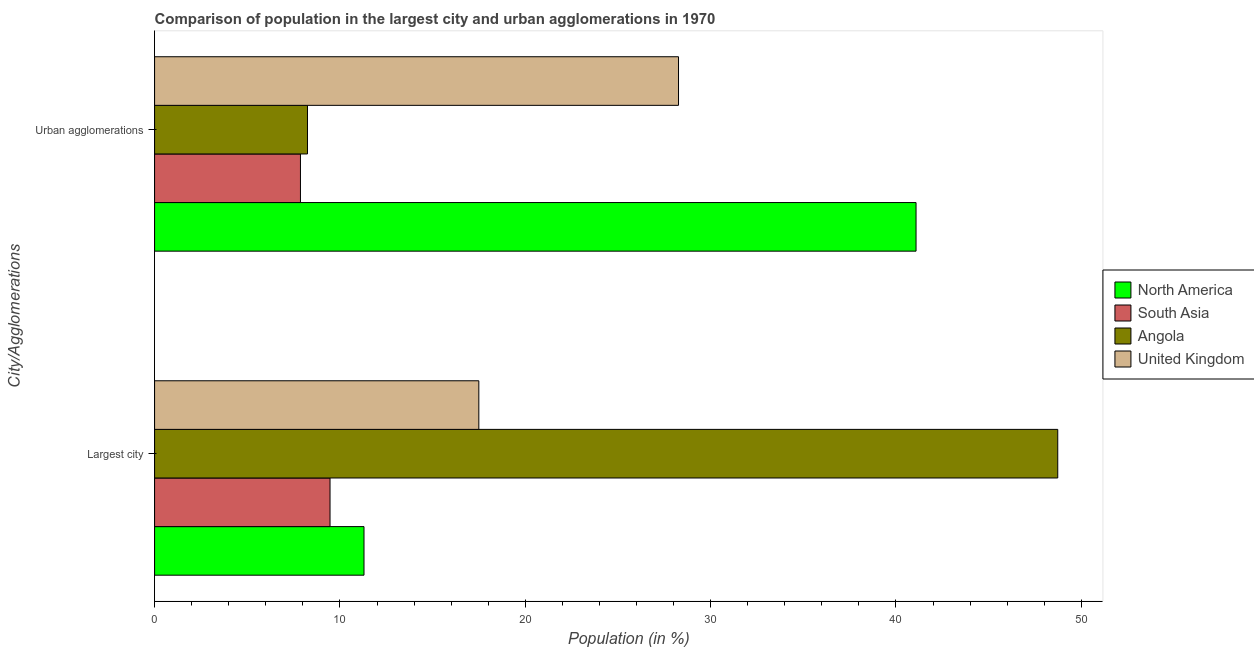Are the number of bars per tick equal to the number of legend labels?
Your answer should be compact. Yes. Are the number of bars on each tick of the Y-axis equal?
Offer a terse response. Yes. How many bars are there on the 1st tick from the top?
Give a very brief answer. 4. How many bars are there on the 1st tick from the bottom?
Your answer should be very brief. 4. What is the label of the 1st group of bars from the top?
Offer a very short reply. Urban agglomerations. What is the population in the largest city in North America?
Your answer should be very brief. 11.3. Across all countries, what is the maximum population in the largest city?
Your answer should be compact. 48.73. Across all countries, what is the minimum population in the largest city?
Provide a short and direct response. 9.47. In which country was the population in the largest city maximum?
Provide a short and direct response. Angola. In which country was the population in urban agglomerations minimum?
Provide a succinct answer. South Asia. What is the total population in urban agglomerations in the graph?
Keep it short and to the point. 85.47. What is the difference between the population in urban agglomerations in Angola and that in United Kingdom?
Keep it short and to the point. -20.02. What is the difference between the population in the largest city in United Kingdom and the population in urban agglomerations in South Asia?
Ensure brevity in your answer.  9.62. What is the average population in the largest city per country?
Give a very brief answer. 21.75. What is the difference between the population in the largest city and population in urban agglomerations in North America?
Make the answer very short. -29.78. What is the ratio of the population in urban agglomerations in South Asia to that in North America?
Keep it short and to the point. 0.19. In how many countries, is the population in urban agglomerations greater than the average population in urban agglomerations taken over all countries?
Your answer should be very brief. 2. What does the 2nd bar from the top in Urban agglomerations represents?
Give a very brief answer. Angola. What does the 3rd bar from the bottom in Largest city represents?
Offer a very short reply. Angola. How many bars are there?
Your answer should be compact. 8. Are all the bars in the graph horizontal?
Give a very brief answer. Yes. Are the values on the major ticks of X-axis written in scientific E-notation?
Keep it short and to the point. No. Does the graph contain any zero values?
Your answer should be very brief. No. How are the legend labels stacked?
Give a very brief answer. Vertical. What is the title of the graph?
Keep it short and to the point. Comparison of population in the largest city and urban agglomerations in 1970. Does "European Union" appear as one of the legend labels in the graph?
Provide a succinct answer. No. What is the label or title of the X-axis?
Offer a very short reply. Population (in %). What is the label or title of the Y-axis?
Make the answer very short. City/Agglomerations. What is the Population (in %) of North America in Largest city?
Keep it short and to the point. 11.3. What is the Population (in %) in South Asia in Largest city?
Keep it short and to the point. 9.47. What is the Population (in %) in Angola in Largest city?
Offer a very short reply. 48.73. What is the Population (in %) in United Kingdom in Largest city?
Your answer should be very brief. 17.49. What is the Population (in %) of North America in Urban agglomerations?
Provide a succinct answer. 41.08. What is the Population (in %) in South Asia in Urban agglomerations?
Provide a short and direct response. 7.87. What is the Population (in %) of Angola in Urban agglomerations?
Offer a terse response. 8.25. What is the Population (in %) of United Kingdom in Urban agglomerations?
Give a very brief answer. 28.27. Across all City/Agglomerations, what is the maximum Population (in %) in North America?
Provide a succinct answer. 41.08. Across all City/Agglomerations, what is the maximum Population (in %) in South Asia?
Give a very brief answer. 9.47. Across all City/Agglomerations, what is the maximum Population (in %) of Angola?
Your response must be concise. 48.73. Across all City/Agglomerations, what is the maximum Population (in %) in United Kingdom?
Offer a terse response. 28.27. Across all City/Agglomerations, what is the minimum Population (in %) in North America?
Make the answer very short. 11.3. Across all City/Agglomerations, what is the minimum Population (in %) in South Asia?
Ensure brevity in your answer.  7.87. Across all City/Agglomerations, what is the minimum Population (in %) in Angola?
Your answer should be compact. 8.25. Across all City/Agglomerations, what is the minimum Population (in %) of United Kingdom?
Offer a terse response. 17.49. What is the total Population (in %) in North America in the graph?
Keep it short and to the point. 52.38. What is the total Population (in %) in South Asia in the graph?
Keep it short and to the point. 17.34. What is the total Population (in %) of Angola in the graph?
Make the answer very short. 56.98. What is the total Population (in %) of United Kingdom in the graph?
Offer a terse response. 45.76. What is the difference between the Population (in %) in North America in Largest city and that in Urban agglomerations?
Keep it short and to the point. -29.78. What is the difference between the Population (in %) of South Asia in Largest city and that in Urban agglomerations?
Offer a terse response. 1.6. What is the difference between the Population (in %) of Angola in Largest city and that in Urban agglomerations?
Give a very brief answer. 40.48. What is the difference between the Population (in %) in United Kingdom in Largest city and that in Urban agglomerations?
Your answer should be compact. -10.77. What is the difference between the Population (in %) in North America in Largest city and the Population (in %) in South Asia in Urban agglomerations?
Keep it short and to the point. 3.43. What is the difference between the Population (in %) in North America in Largest city and the Population (in %) in Angola in Urban agglomerations?
Your answer should be very brief. 3.05. What is the difference between the Population (in %) in North America in Largest city and the Population (in %) in United Kingdom in Urban agglomerations?
Keep it short and to the point. -16.97. What is the difference between the Population (in %) of South Asia in Largest city and the Population (in %) of Angola in Urban agglomerations?
Ensure brevity in your answer.  1.22. What is the difference between the Population (in %) of South Asia in Largest city and the Population (in %) of United Kingdom in Urban agglomerations?
Offer a very short reply. -18.8. What is the difference between the Population (in %) of Angola in Largest city and the Population (in %) of United Kingdom in Urban agglomerations?
Make the answer very short. 20.46. What is the average Population (in %) of North America per City/Agglomerations?
Your answer should be very brief. 26.19. What is the average Population (in %) in South Asia per City/Agglomerations?
Your answer should be very brief. 8.67. What is the average Population (in %) of Angola per City/Agglomerations?
Offer a very short reply. 28.49. What is the average Population (in %) of United Kingdom per City/Agglomerations?
Provide a succinct answer. 22.88. What is the difference between the Population (in %) of North America and Population (in %) of South Asia in Largest city?
Offer a very short reply. 1.83. What is the difference between the Population (in %) in North America and Population (in %) in Angola in Largest city?
Your response must be concise. -37.43. What is the difference between the Population (in %) of North America and Population (in %) of United Kingdom in Largest city?
Give a very brief answer. -6.2. What is the difference between the Population (in %) in South Asia and Population (in %) in Angola in Largest city?
Keep it short and to the point. -39.26. What is the difference between the Population (in %) in South Asia and Population (in %) in United Kingdom in Largest city?
Your answer should be compact. -8.03. What is the difference between the Population (in %) in Angola and Population (in %) in United Kingdom in Largest city?
Give a very brief answer. 31.23. What is the difference between the Population (in %) in North America and Population (in %) in South Asia in Urban agglomerations?
Make the answer very short. 33.21. What is the difference between the Population (in %) in North America and Population (in %) in Angola in Urban agglomerations?
Keep it short and to the point. 32.83. What is the difference between the Population (in %) in North America and Population (in %) in United Kingdom in Urban agglomerations?
Your answer should be very brief. 12.81. What is the difference between the Population (in %) in South Asia and Population (in %) in Angola in Urban agglomerations?
Provide a succinct answer. -0.38. What is the difference between the Population (in %) of South Asia and Population (in %) of United Kingdom in Urban agglomerations?
Give a very brief answer. -20.4. What is the difference between the Population (in %) in Angola and Population (in %) in United Kingdom in Urban agglomerations?
Provide a succinct answer. -20.02. What is the ratio of the Population (in %) of North America in Largest city to that in Urban agglomerations?
Offer a terse response. 0.28. What is the ratio of the Population (in %) in South Asia in Largest city to that in Urban agglomerations?
Give a very brief answer. 1.2. What is the ratio of the Population (in %) in Angola in Largest city to that in Urban agglomerations?
Offer a terse response. 5.91. What is the ratio of the Population (in %) of United Kingdom in Largest city to that in Urban agglomerations?
Provide a short and direct response. 0.62. What is the difference between the highest and the second highest Population (in %) in North America?
Your answer should be compact. 29.78. What is the difference between the highest and the second highest Population (in %) of South Asia?
Your answer should be compact. 1.6. What is the difference between the highest and the second highest Population (in %) in Angola?
Give a very brief answer. 40.48. What is the difference between the highest and the second highest Population (in %) in United Kingdom?
Offer a terse response. 10.77. What is the difference between the highest and the lowest Population (in %) in North America?
Offer a terse response. 29.78. What is the difference between the highest and the lowest Population (in %) in South Asia?
Your answer should be very brief. 1.6. What is the difference between the highest and the lowest Population (in %) in Angola?
Your answer should be compact. 40.48. What is the difference between the highest and the lowest Population (in %) in United Kingdom?
Your answer should be compact. 10.77. 